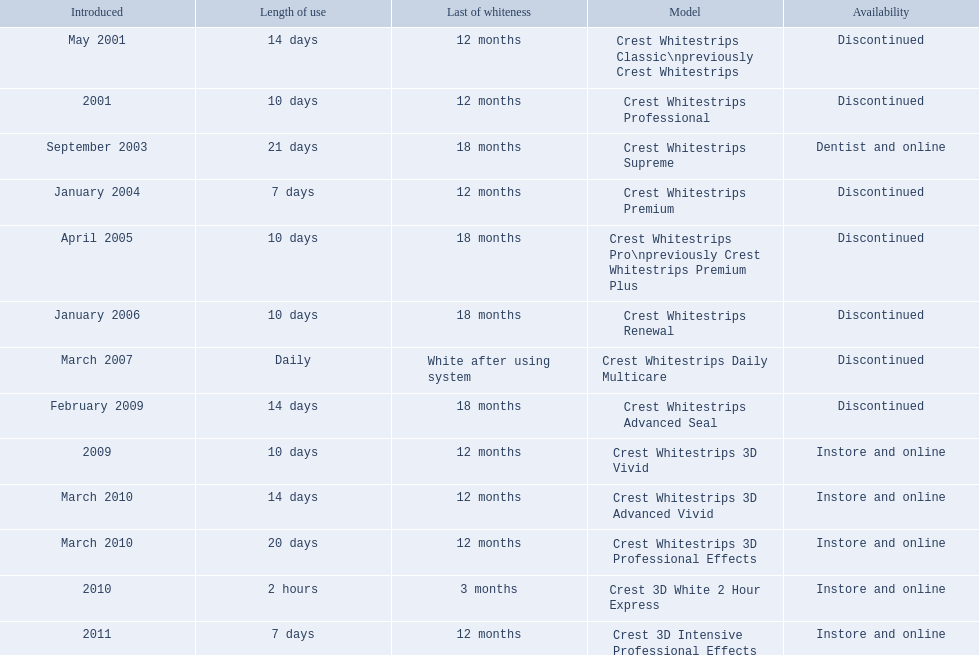Which models are still available? Crest Whitestrips Supreme, Crest Whitestrips 3D Vivid, Crest Whitestrips 3D Advanced Vivid, Crest Whitestrips 3D Professional Effects, Crest 3D White 2 Hour Express, Crest 3D Intensive Professional Effects. Of those, which were introduced prior to 2011? Crest Whitestrips Supreme, Crest Whitestrips 3D Vivid, Crest Whitestrips 3D Advanced Vivid, Crest Whitestrips 3D Professional Effects, Crest 3D White 2 Hour Express. Among those models, which ones had to be used at least 14 days? Crest Whitestrips Supreme, Crest Whitestrips 3D Advanced Vivid, Crest Whitestrips 3D Professional Effects. Which of those lasted longer than 12 months? Crest Whitestrips Supreme. 